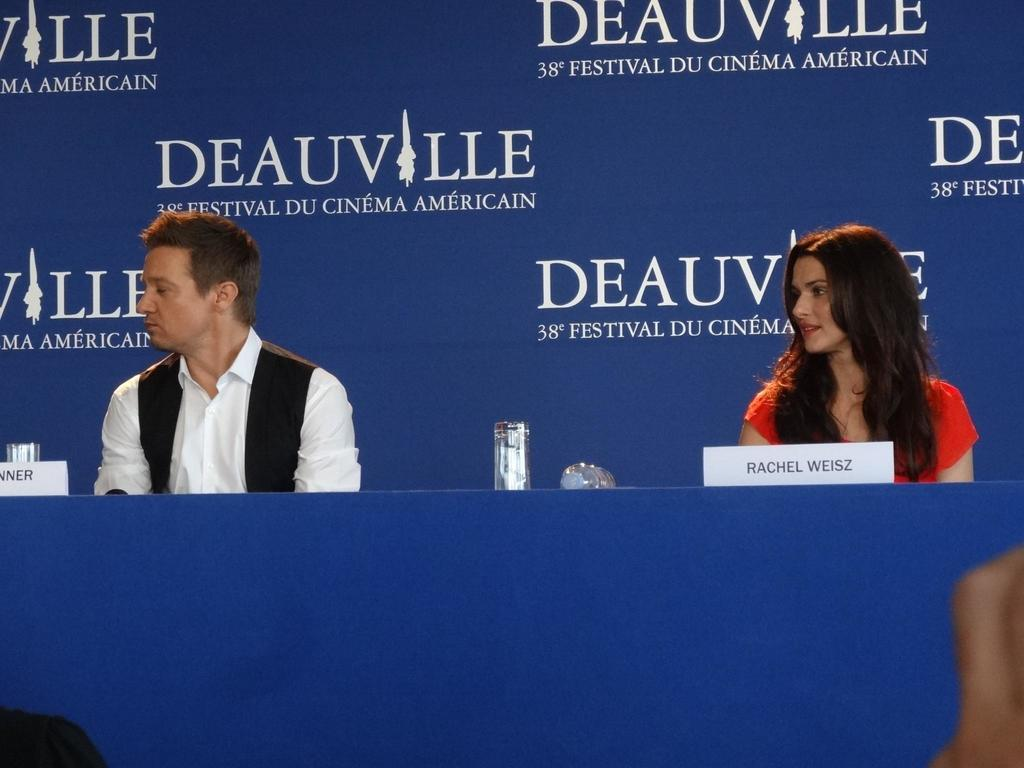How many people are present in the image? There is a man and a woman in the image. What objects can be seen on the table in the image? There are glasses on the table in the image. What is visible in the background of the image? There is a banner in the background of the image. How many goldfish are swimming in the hole in the image? There are no goldfish or holes present in the image. 